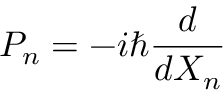Convert formula to latex. <formula><loc_0><loc_0><loc_500><loc_500>P _ { n } = - i \hbar { \frac { d } { d X _ { n } } }</formula> 